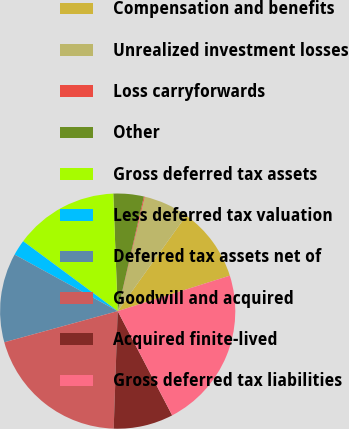<chart> <loc_0><loc_0><loc_500><loc_500><pie_chart><fcel>Compensation and benefits<fcel>Unrealized investment losses<fcel>Loss carryforwards<fcel>Other<fcel>Gross deferred tax assets<fcel>Less deferred tax valuation<fcel>Deferred tax assets net of<fcel>Goodwill and acquired<fcel>Acquired finite-lived<fcel>Gross deferred tax liabilities<nl><fcel>10.23%<fcel>6.19%<fcel>0.13%<fcel>4.17%<fcel>14.27%<fcel>2.15%<fcel>12.25%<fcel>20.19%<fcel>8.21%<fcel>22.21%<nl></chart> 